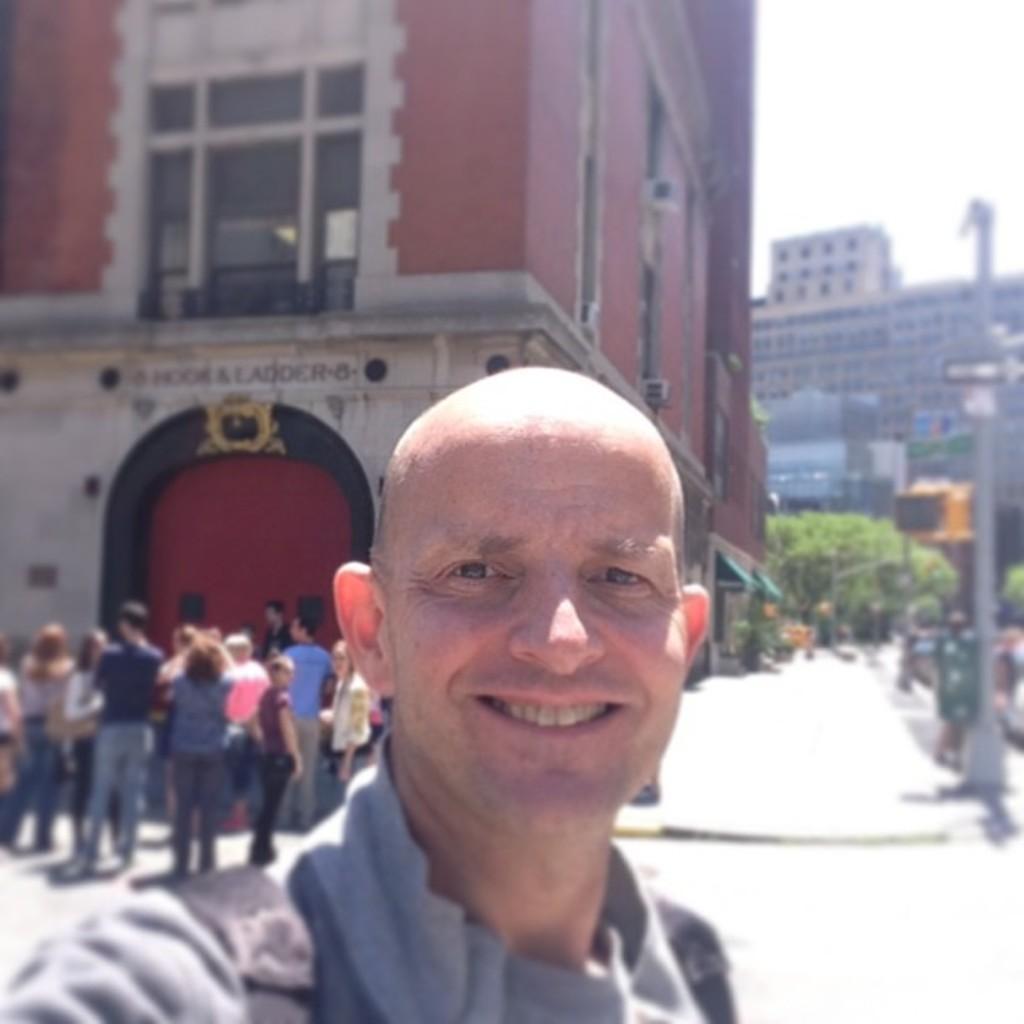Can you describe this image briefly? In this image we can see a man smiling. In the background there are buildings, trees and poles. We can see people and there is sky. 